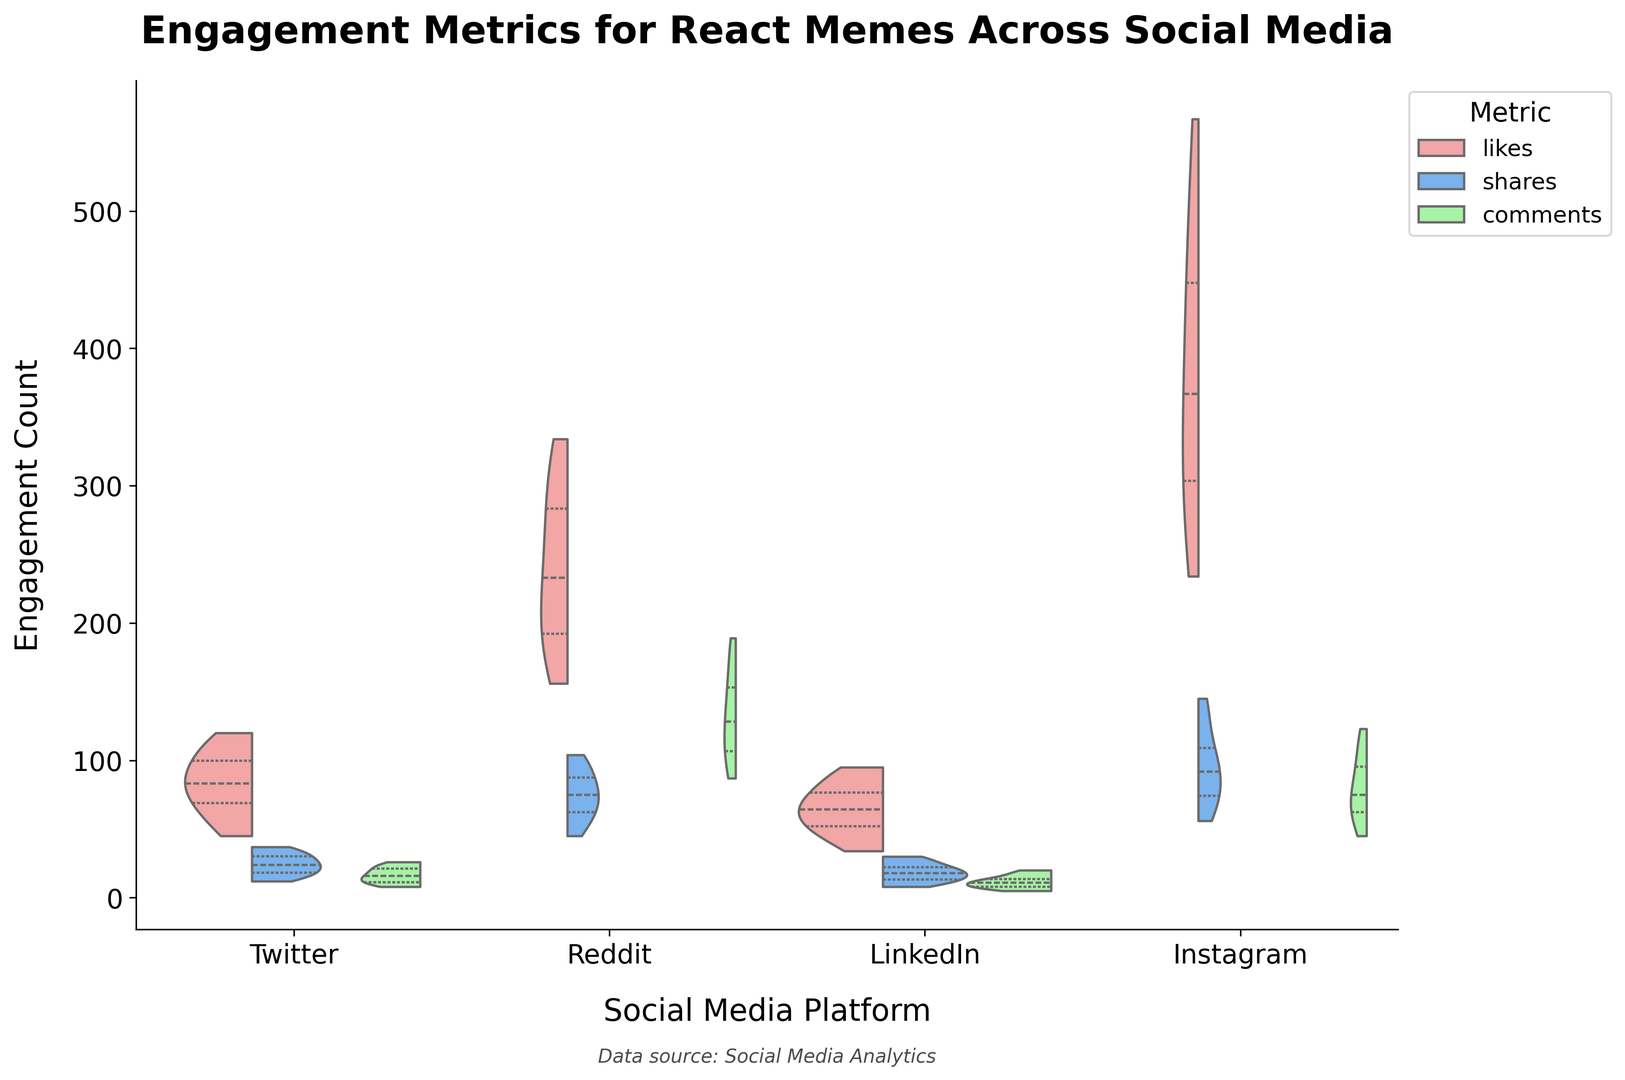Which platform has the highest median number of likes? The median is indicated by the thick white line inside each violin plot. The platform with the highest median number of likes shows the thick white line at the highest position in the plot.
Answer: Instagram Which metric generally has the highest values across all platforms? By looking at the general height and spread of the violin plots across all platforms, the "likes" metric usually stretches the highest and most broadly.
Answer: Likes On which platform do memes get shared the least often on average? You can infer this by comparing the height and spread of the shares' violin plots across all platforms. The platform with the shortest height for the shares' plot on average indicates fewer shares.
Answer: LinkedIn How do the median number of comments on Instagram compare with Reddit? The thick white lines on the comments' violin plots show the median values. Comparing their positions, Instagram's median line for comments is lower than Reddit's median line.
Answer: Lower on Instagram Of the platforms, which one has the biggest range in likes, and how can you tell? The range for the likes can be determined by looking at the overall height of the violin plot corresponding to likes. The platform with the tallest plot from bottom to top has the biggest range.
Answer: Instagram What is the overlap between likes and shares on Twitter? The overlapping area of the two sections in the split violin plot for Twitter shows where the distributions of likes and shares intersect. Shares show less spread and are contained within a smaller region compared to likes.
Answer: Limited overlap Between LinkedIn and Twitter, which platform has higher engagement in terms of shares? By comparing the height of the violin plots for shares between LinkedIn and Twitter, Twitter's violin plot extends higher than LinkedIn's, indicating higher engagement in terms of shares.
Answer: Twitter How do the interquartile ranges of comments on Twitter and LinkedIn compare? The interquartile range is visible within the middle two quartiles in the violin plots. The interquartile range on Twitter for comments extends further compared to LinkedIn, indicating more variability.
Answer: Wider on Twitter Which metric shows the least variability on LinkedIn? The least variability for a metric can be observed from the narrowest violin plot. For LinkedIn, the plot for comments is narrower than likes and shares, showing the least variability.
Answer: Comments What does the quartile split within the likes category reveal about the spread on Reddit? The quartile splits in the violin plot show more pronounced distributions and a wider range of data points for likes on Reddit, indicating significant variability. The spread suggests a wide range of engagement levels.
Answer: High variability 